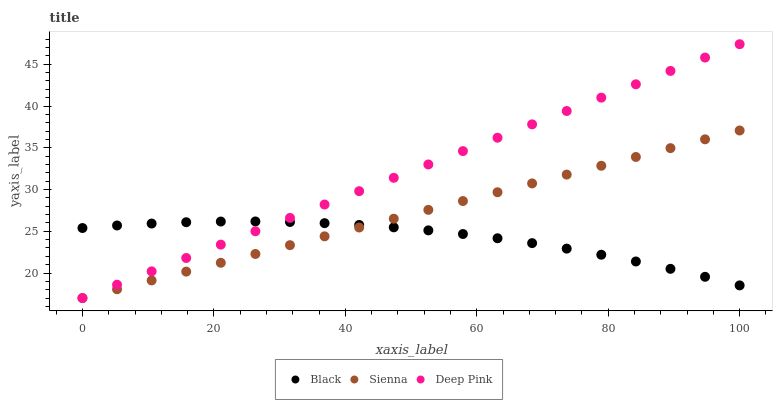Does Black have the minimum area under the curve?
Answer yes or no. Yes. Does Deep Pink have the maximum area under the curve?
Answer yes or no. Yes. Does Deep Pink have the minimum area under the curve?
Answer yes or no. No. Does Black have the maximum area under the curve?
Answer yes or no. No. Is Deep Pink the smoothest?
Answer yes or no. Yes. Is Black the roughest?
Answer yes or no. Yes. Is Black the smoothest?
Answer yes or no. No. Is Deep Pink the roughest?
Answer yes or no. No. Does Sienna have the lowest value?
Answer yes or no. Yes. Does Black have the lowest value?
Answer yes or no. No. Does Deep Pink have the highest value?
Answer yes or no. Yes. Does Black have the highest value?
Answer yes or no. No. Does Deep Pink intersect Sienna?
Answer yes or no. Yes. Is Deep Pink less than Sienna?
Answer yes or no. No. Is Deep Pink greater than Sienna?
Answer yes or no. No. 